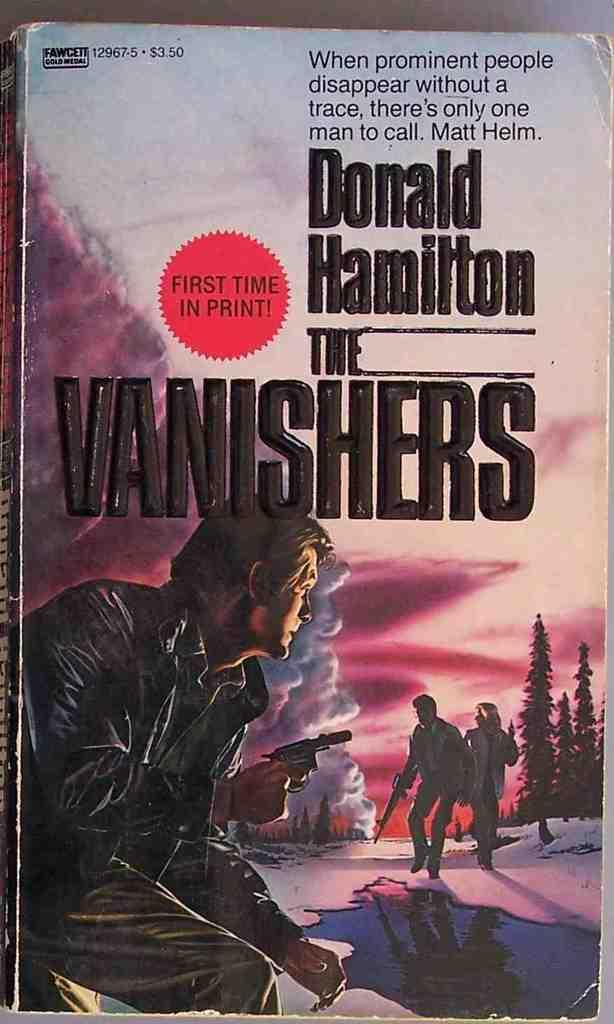<image>
Create a compact narrative representing the image presented. A book cover by Donald Hamilton called The Vanishers. 